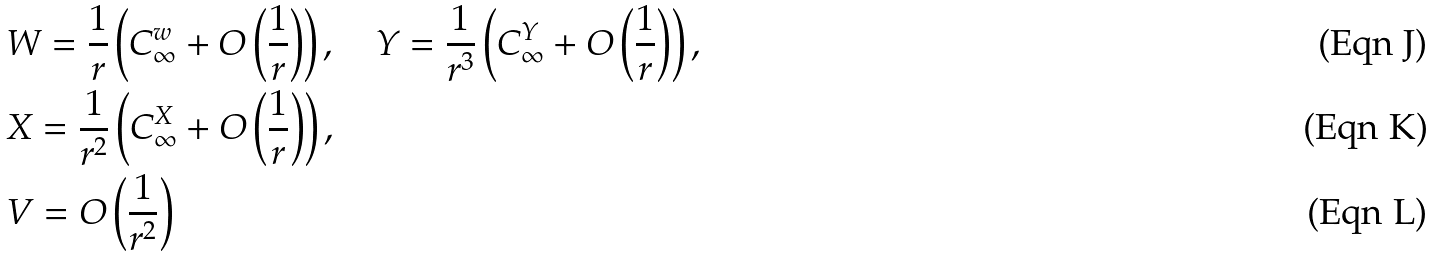Convert formula to latex. <formula><loc_0><loc_0><loc_500><loc_500>& W = \frac { 1 } { r } \left ( C _ { \infty } ^ { w } + O \left ( \frac { 1 } { r } \right ) \right ) , \quad Y = \frac { 1 } { r ^ { 3 } } \left ( C _ { \infty } ^ { Y } + O \left ( \frac { 1 } { r } \right ) \right ) , \\ & X = \frac { 1 } { r ^ { 2 } } \left ( C _ { \infty } ^ { X } + O \left ( \frac { 1 } { r } \right ) \right ) , \\ & V = O \left ( \frac { 1 } { r ^ { 2 } } \right )</formula> 